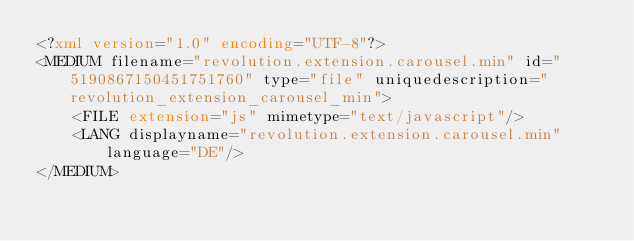<code> <loc_0><loc_0><loc_500><loc_500><_XML_><?xml version="1.0" encoding="UTF-8"?>
<MEDIUM filename="revolution.extension.carousel.min" id="5190867150451751760" type="file" uniquedescription="revolution_extension_carousel_min">
	<FILE extension="js" mimetype="text/javascript"/>
	<LANG displayname="revolution.extension.carousel.min" language="DE"/>
</MEDIUM>
</code> 